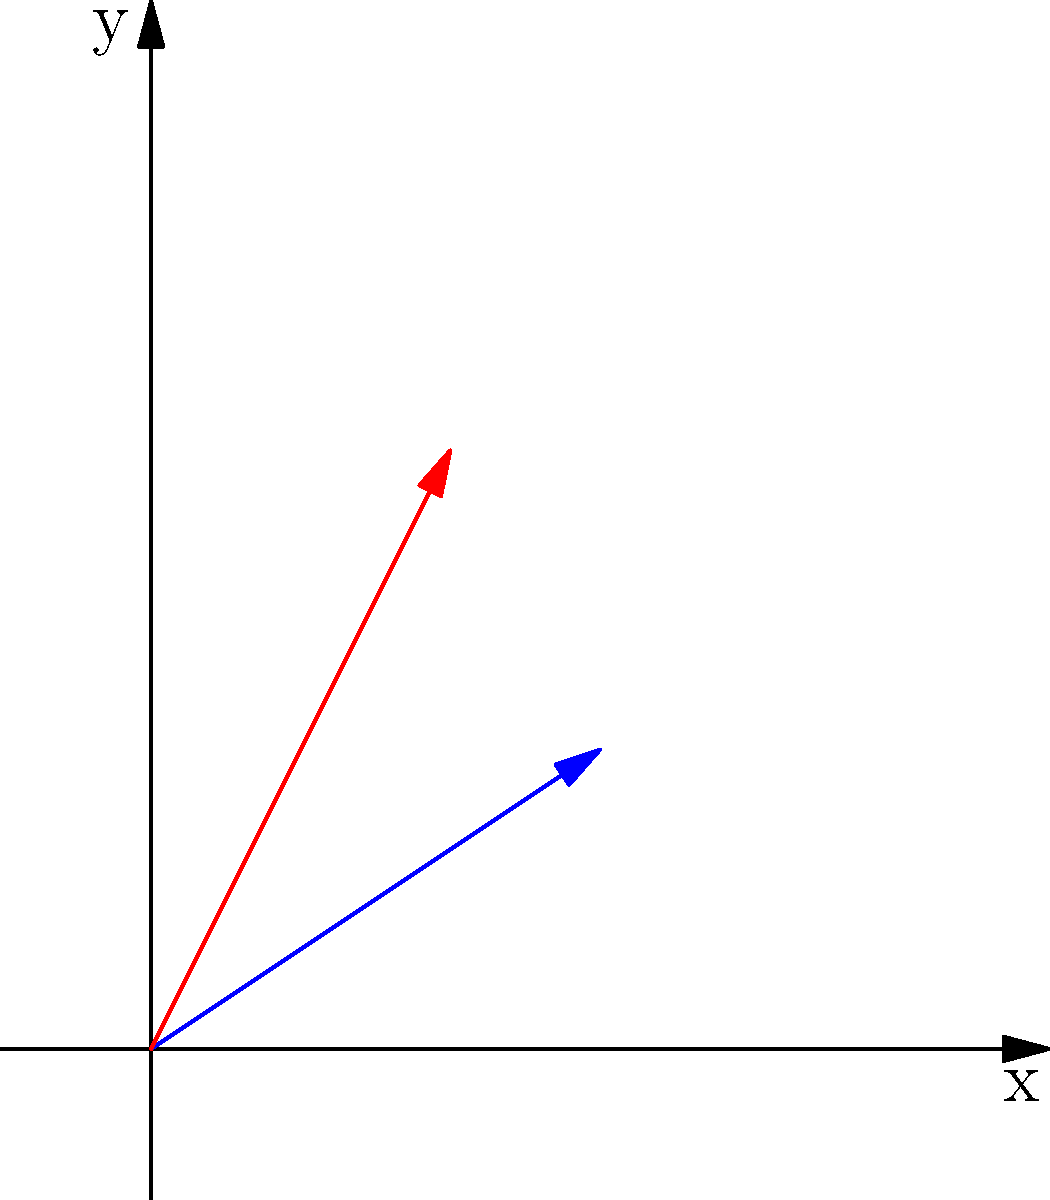In the context of educational physics simulations, you're developing a vector addition module. Given two vectors $\mathbf{A} = (3, 2)$ and $\mathbf{B} = (2, 4)$ represented in the graphic, what is the magnitude of the resultant vector $\mathbf{R} = \mathbf{A} + \mathbf{B}$? To find the magnitude of the resultant vector $\mathbf{R} = \mathbf{A} + \mathbf{B}$, we'll follow these steps:

1) First, we add the vectors componentwise:
   $\mathbf{R}_x = A_x + B_x = 3 + 2 = 5$
   $\mathbf{R}_y = A_y + B_y = 2 + 4 = 6$

2) So, the resultant vector $\mathbf{R} = (5, 6)$

3) To find the magnitude of $\mathbf{R}$, we use the Pythagorean theorem:
   $|\mathbf{R}| = \sqrt{R_x^2 + R_y^2}$

4) Substituting the values:
   $|\mathbf{R}| = \sqrt{5^2 + 6^2}$

5) Simplifying:
   $|\mathbf{R}| = \sqrt{25 + 36} = \sqrt{61}$

6) This can be left as $\sqrt{61}$, or if a decimal approximation is needed:
   $|\mathbf{R}| \approx 7.81$

This method of graphical addition and subsequent calculation can be implemented in educational physics simulations to help students visualize and understand vector operations.
Answer: $\sqrt{61}$ or approximately 7.81 